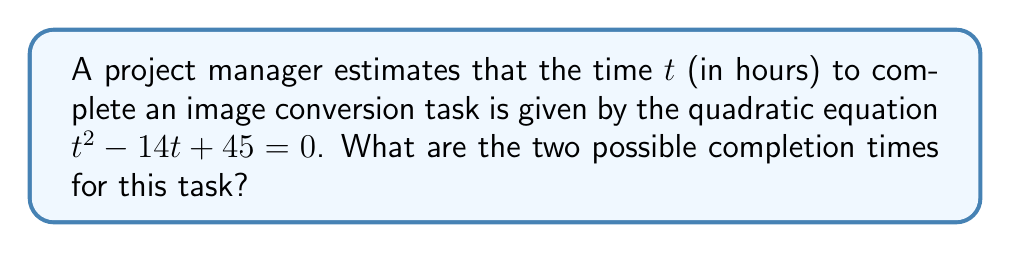Teach me how to tackle this problem. To solve this quadratic equation and find the possible completion times, we'll use the quadratic formula:

$$t = \frac{-b \pm \sqrt{b^2 - 4ac}}{2a}$$

Where $a = 1$, $b = -14$, and $c = 45$

Step 1: Substitute the values into the quadratic formula
$$t = \frac{-(-14) \pm \sqrt{(-14)^2 - 4(1)(45)}}{2(1)}$$

Step 2: Simplify under the square root
$$t = \frac{14 \pm \sqrt{196 - 180}}{2}$$
$$t = \frac{14 \pm \sqrt{16}}{2}$$
$$t = \frac{14 \pm 4}{2}$$

Step 3: Calculate the two solutions
$$t_1 = \frac{14 + 4}{2} = \frac{18}{2} = 9$$
$$t_2 = \frac{14 - 4}{2} = \frac{10}{2} = 5$$

Therefore, the two possible completion times are 9 hours and 5 hours.
Answer: 9 hours and 5 hours 